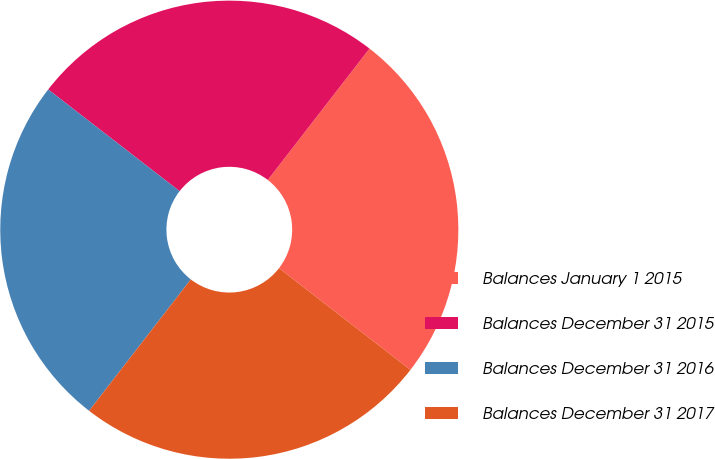Convert chart to OTSL. <chart><loc_0><loc_0><loc_500><loc_500><pie_chart><fcel>Balances January 1 2015<fcel>Balances December 31 2015<fcel>Balances December 31 2016<fcel>Balances December 31 2017<nl><fcel>25.0%<fcel>25.0%<fcel>25.0%<fcel>25.0%<nl></chart> 